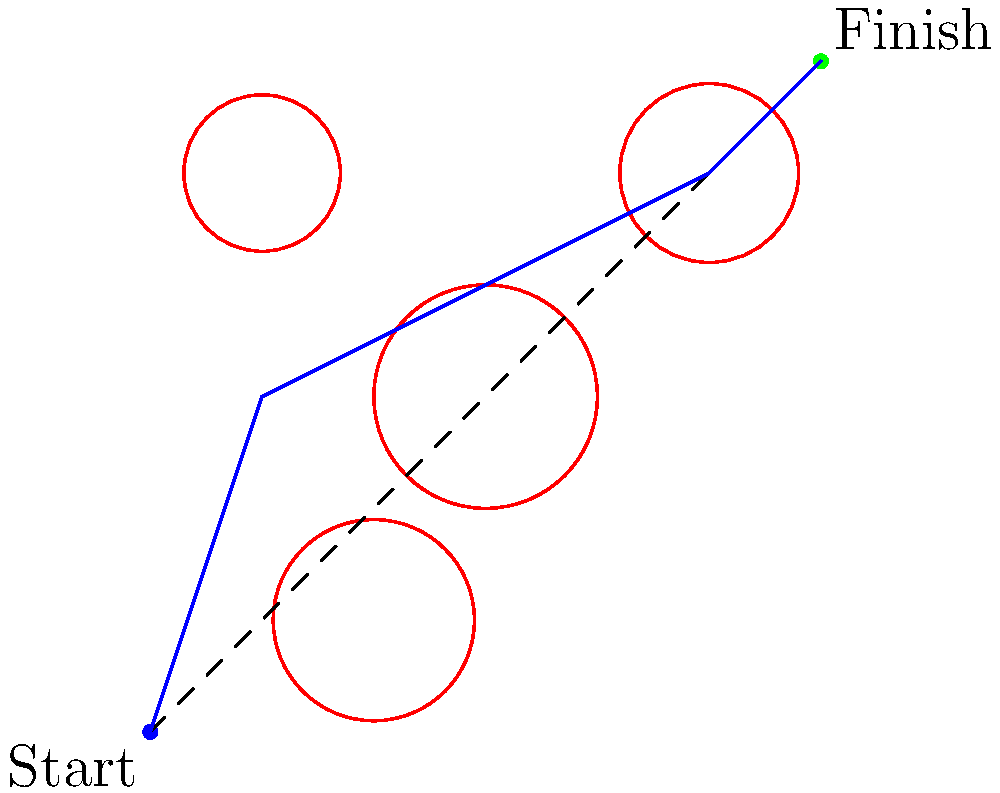In the obstacle course shown above, identify the most efficient path from the start point (blue dot) to the finish point (green dot). Which of the following best describes the optimal route?

A) Straight line from start to finish
B) Curve around obstacle 1, then straight to finish
C) Zigzag between obstacles 1 and 4, then 2 and 3
D) Curve around obstacles 4, 1, and 2 To determine the most efficient path through this obstacle course, we need to consider the following steps:

1. Analyze the direct path: The dashed line represents the shortest distance between start and finish, but it intersects multiple obstacles.

2. Evaluate obstacle positions: Obstacles 1 and 2 are directly in the path, while 3 and 4 are slightly off to the sides.

3. Consider path alternatives:
   a) Going straight (option A) is impossible due to obstacles.
   b) Curving only around obstacle 1 (option B) would still intersect obstacle 2.
   c) Zigzagging between all obstacles (option C) would create an unnecessarily long path.
   d) Curving around obstacles 4, 1, and 2 (option D) provides a smooth path that avoids all obstacles while minimizing distance.

4. Assess efficiency: The blue line in the diagram represents the path described in option D, which balances obstacle avoidance with path length minimization.

5. Compare to athletic performance: As an athlete, you understand the importance of efficiency in movement. This path allows for smooth transitions and minimal energy expenditure while navigating the course.

Therefore, the most efficient path is represented by option D, curving around obstacles 4, 1, and 2 to reach the finish point.
Answer: D 